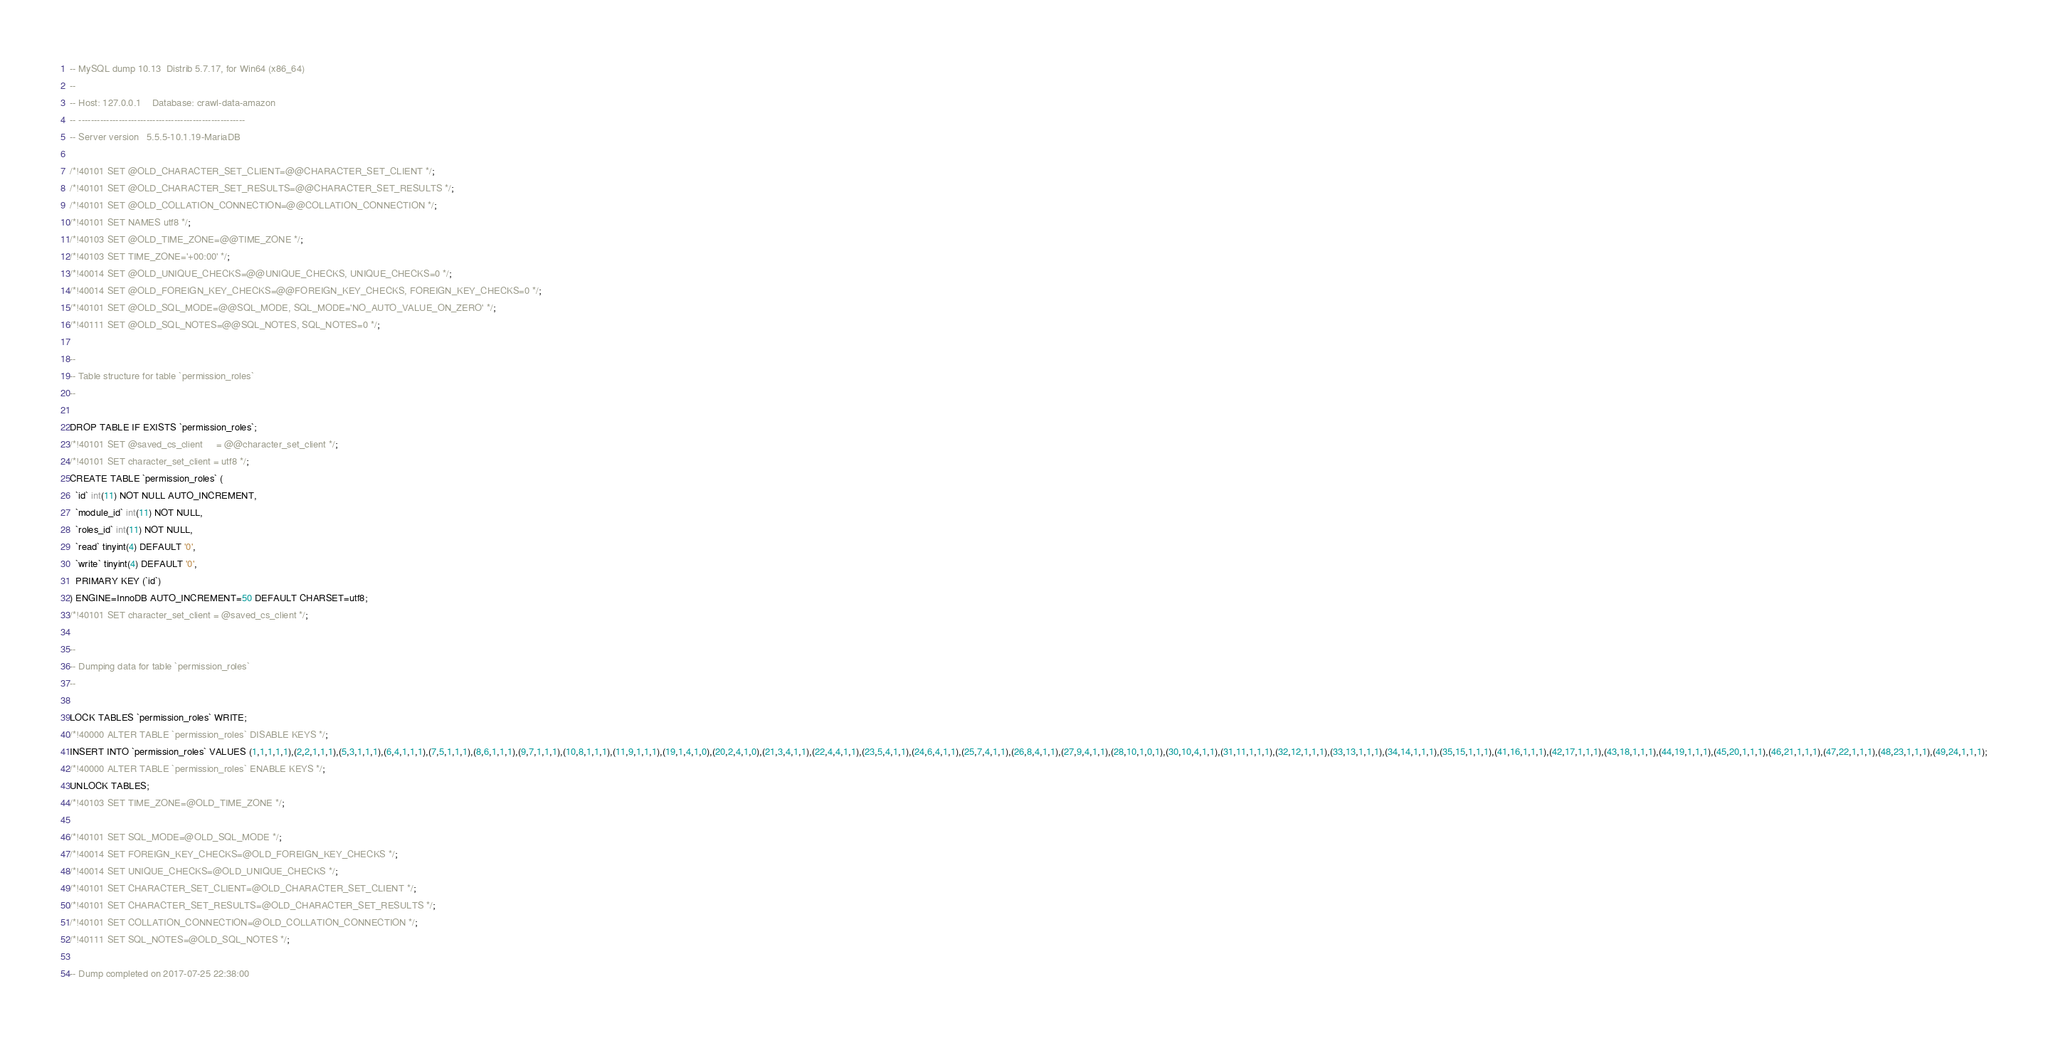Convert code to text. <code><loc_0><loc_0><loc_500><loc_500><_SQL_>-- MySQL dump 10.13  Distrib 5.7.17, for Win64 (x86_64)
--
-- Host: 127.0.0.1    Database: crawl-data-amazon
-- ------------------------------------------------------
-- Server version	5.5.5-10.1.19-MariaDB

/*!40101 SET @OLD_CHARACTER_SET_CLIENT=@@CHARACTER_SET_CLIENT */;
/*!40101 SET @OLD_CHARACTER_SET_RESULTS=@@CHARACTER_SET_RESULTS */;
/*!40101 SET @OLD_COLLATION_CONNECTION=@@COLLATION_CONNECTION */;
/*!40101 SET NAMES utf8 */;
/*!40103 SET @OLD_TIME_ZONE=@@TIME_ZONE */;
/*!40103 SET TIME_ZONE='+00:00' */;
/*!40014 SET @OLD_UNIQUE_CHECKS=@@UNIQUE_CHECKS, UNIQUE_CHECKS=0 */;
/*!40014 SET @OLD_FOREIGN_KEY_CHECKS=@@FOREIGN_KEY_CHECKS, FOREIGN_KEY_CHECKS=0 */;
/*!40101 SET @OLD_SQL_MODE=@@SQL_MODE, SQL_MODE='NO_AUTO_VALUE_ON_ZERO' */;
/*!40111 SET @OLD_SQL_NOTES=@@SQL_NOTES, SQL_NOTES=0 */;

--
-- Table structure for table `permission_roles`
--

DROP TABLE IF EXISTS `permission_roles`;
/*!40101 SET @saved_cs_client     = @@character_set_client */;
/*!40101 SET character_set_client = utf8 */;
CREATE TABLE `permission_roles` (
  `id` int(11) NOT NULL AUTO_INCREMENT,
  `module_id` int(11) NOT NULL,
  `roles_id` int(11) NOT NULL,
  `read` tinyint(4) DEFAULT '0',
  `write` tinyint(4) DEFAULT '0',
  PRIMARY KEY (`id`)
) ENGINE=InnoDB AUTO_INCREMENT=50 DEFAULT CHARSET=utf8;
/*!40101 SET character_set_client = @saved_cs_client */;

--
-- Dumping data for table `permission_roles`
--

LOCK TABLES `permission_roles` WRITE;
/*!40000 ALTER TABLE `permission_roles` DISABLE KEYS */;
INSERT INTO `permission_roles` VALUES (1,1,1,1,1),(2,2,1,1,1),(5,3,1,1,1),(6,4,1,1,1),(7,5,1,1,1),(8,6,1,1,1),(9,7,1,1,1),(10,8,1,1,1),(11,9,1,1,1),(19,1,4,1,0),(20,2,4,1,0),(21,3,4,1,1),(22,4,4,1,1),(23,5,4,1,1),(24,6,4,1,1),(25,7,4,1,1),(26,8,4,1,1),(27,9,4,1,1),(28,10,1,0,1),(30,10,4,1,1),(31,11,1,1,1),(32,12,1,1,1),(33,13,1,1,1),(34,14,1,1,1),(35,15,1,1,1),(41,16,1,1,1),(42,17,1,1,1),(43,18,1,1,1),(44,19,1,1,1),(45,20,1,1,1),(46,21,1,1,1),(47,22,1,1,1),(48,23,1,1,1),(49,24,1,1,1);
/*!40000 ALTER TABLE `permission_roles` ENABLE KEYS */;
UNLOCK TABLES;
/*!40103 SET TIME_ZONE=@OLD_TIME_ZONE */;

/*!40101 SET SQL_MODE=@OLD_SQL_MODE */;
/*!40014 SET FOREIGN_KEY_CHECKS=@OLD_FOREIGN_KEY_CHECKS */;
/*!40014 SET UNIQUE_CHECKS=@OLD_UNIQUE_CHECKS */;
/*!40101 SET CHARACTER_SET_CLIENT=@OLD_CHARACTER_SET_CLIENT */;
/*!40101 SET CHARACTER_SET_RESULTS=@OLD_CHARACTER_SET_RESULTS */;
/*!40101 SET COLLATION_CONNECTION=@OLD_COLLATION_CONNECTION */;
/*!40111 SET SQL_NOTES=@OLD_SQL_NOTES */;

-- Dump completed on 2017-07-25 22:38:00
</code> 